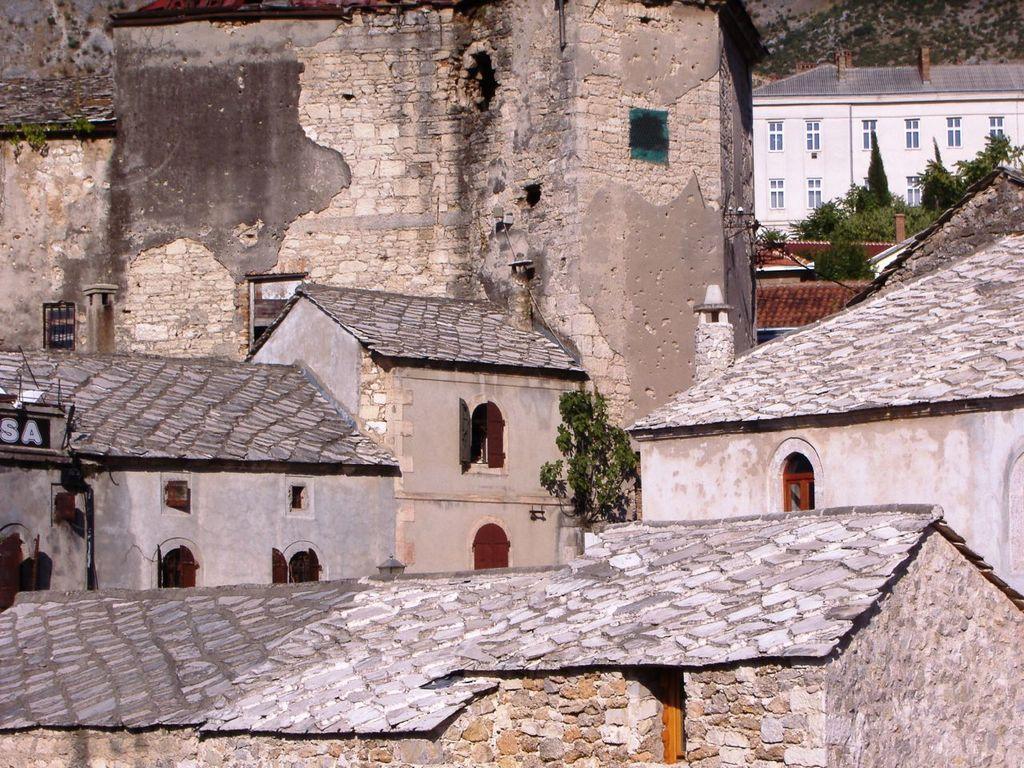Can you describe this image briefly? The image consists of houses, we can see windows, roofs and trees. At the bottom it is brick wall. 